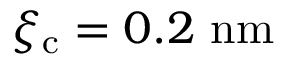<formula> <loc_0><loc_0><loc_500><loc_500>{ \xi _ { c } = 0 . 2 \ n m }</formula> 